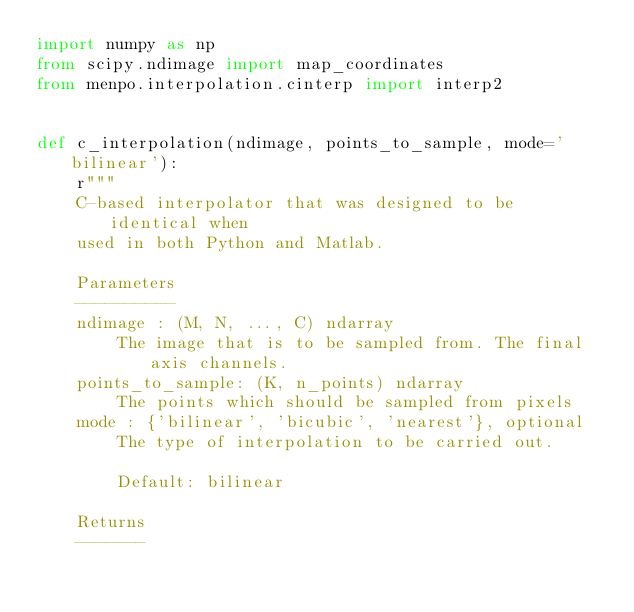Convert code to text. <code><loc_0><loc_0><loc_500><loc_500><_Python_>import numpy as np
from scipy.ndimage import map_coordinates
from menpo.interpolation.cinterp import interp2


def c_interpolation(ndimage, points_to_sample, mode='bilinear'):
    r"""
    C-based interpolator that was designed to be identical when
    used in both Python and Matlab.

    Parameters
    ----------
    ndimage : (M, N, ..., C) ndarray
        The image that is to be sampled from. The final axis channels.
    points_to_sample: (K, n_points) ndarray
        The points which should be sampled from pixels
    mode : {'bilinear', 'bicubic', 'nearest'}, optional
        The type of interpolation to be carried out.

        Default: bilinear

    Returns
    -------</code> 